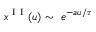<formula> <loc_0><loc_0><loc_500><loc_500>x ^ { I I } ( u ) \sim e ^ { - a u / \tau }</formula> 